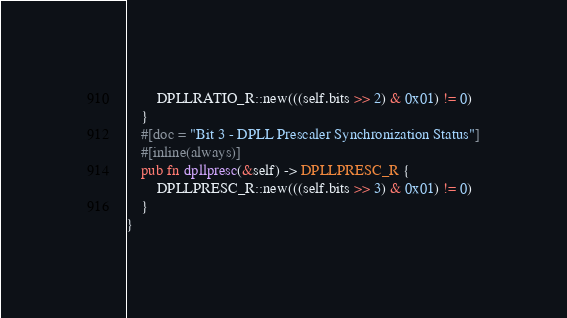<code> <loc_0><loc_0><loc_500><loc_500><_Rust_>        DPLLRATIO_R::new(((self.bits >> 2) & 0x01) != 0)
    }
    #[doc = "Bit 3 - DPLL Prescaler Synchronization Status"]
    #[inline(always)]
    pub fn dpllpresc(&self) -> DPLLPRESC_R {
        DPLLPRESC_R::new(((self.bits >> 3) & 0x01) != 0)
    }
}
</code> 